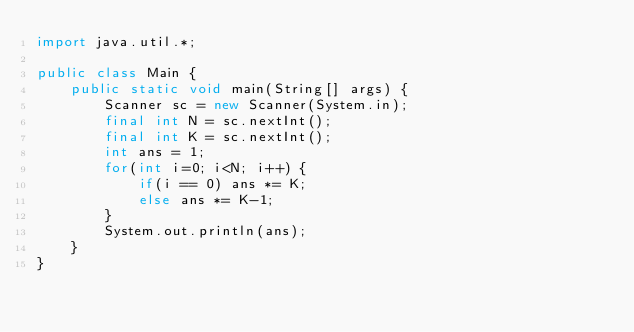<code> <loc_0><loc_0><loc_500><loc_500><_Java_>import java.util.*;

public class Main {
    public static void main(String[] args) {
        Scanner sc = new Scanner(System.in);
        final int N = sc.nextInt();
        final int K = sc.nextInt();
        int ans = 1;
        for(int i=0; i<N; i++) {
            if(i == 0) ans *= K;
            else ans *= K-1;
        }
        System.out.println(ans);
    }
}
</code> 